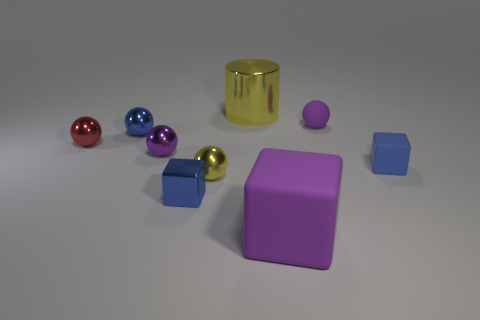Subtract all brown spheres. Subtract all red blocks. How many spheres are left? 5 Add 1 purple metal spheres. How many objects exist? 10 Subtract all balls. How many objects are left? 4 Add 7 tiny yellow things. How many tiny yellow things exist? 8 Subtract 0 gray cylinders. How many objects are left? 9 Subtract all large yellow things. Subtract all matte blocks. How many objects are left? 6 Add 1 small blue metallic blocks. How many small blue metallic blocks are left? 2 